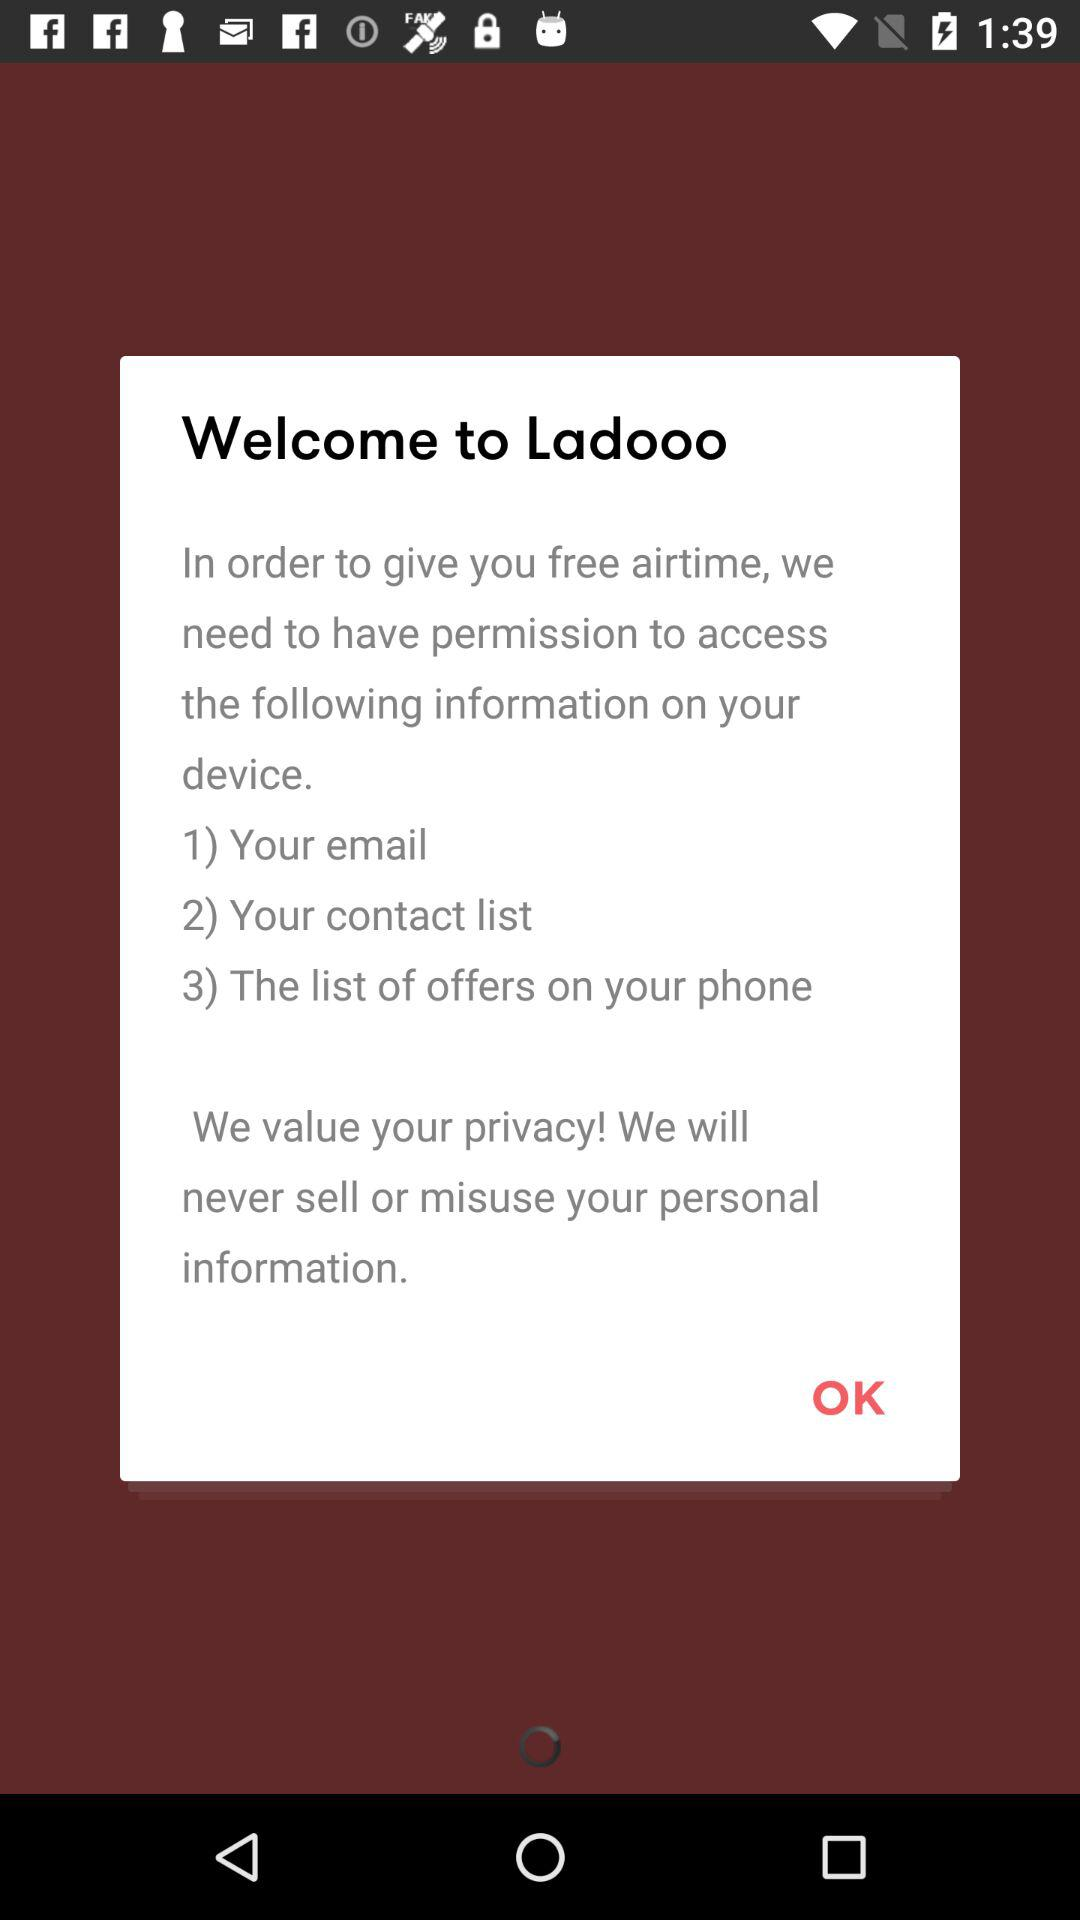How many types of information does the app need to access?
Answer the question using a single word or phrase. 3 